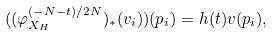<formula> <loc_0><loc_0><loc_500><loc_500>( ( \varphi ^ { ( - N - t ) / 2 N } _ { X _ { H } } ) _ { \ast } ( v _ { i } ) ) ( p _ { i } ) = h ( t ) v ( p _ { i } ) ,</formula> 